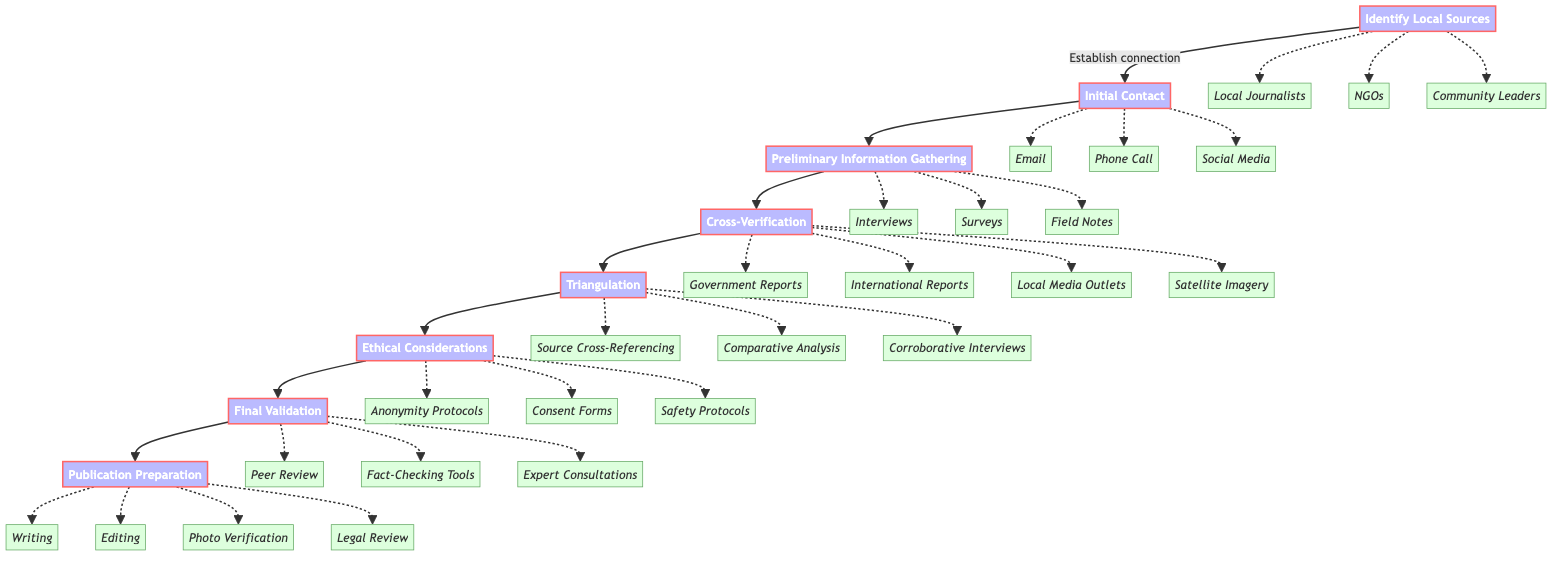What is the first step in the workflow? The first step is listed at the top of the flowchart as "Identify Local Sources," indicating it is where the process begins.
Answer: Identify Local Sources How many steps are there in total? By counting the steps connected in the flow, there are eight distinct steps from "Identify Local Sources" to "Publication Preparation."
Answer: 8 What method can be used for initial contact? The diagram shows three methods that can be used for initial contact, one of them is "Email," which is a specific example listed under the step "Initial Contact."
Answer: Email Which step involves verifying information? The step that focuses specifically on verification is labeled "Cross-Verification," indicating the process where gathered information is confirmed.
Answer: Cross-Verification What technique is part of preliminary information gathering? One of the techniques listed for preliminary information gathering is "Interviews," which is used to collect anecdotes and insights from local sources.
Answer: Interviews Which ethical guideline ensures the safety of local sources? "Safety Protocols" is explicitly mentioned as a guideline in the "Ethical Considerations" step that pertains to ensuring safety for the local sources involved.
Answer: Safety Protocols What is the final step in the workflow? The final step in the sequence, as indicated at the end of the flow, is "Publication Preparation," marking the last stage of this workflow.
Answer: Publication Preparation How are sources verified in the verification step? The verification process involves cross-referencing with multiple sources such as "Government Reports," "Local Media Outlets," and others, demonstrating the redundancy in the verification approach.
Answer: Cross-referencing What does triangulation aim to achieve? Triangulation aims to corroborate information through methods such as "Comparative Analysis," helping to ensure that the data from multiple independent sources aligns and confirms accuracy.
Answer: Corroborate information 